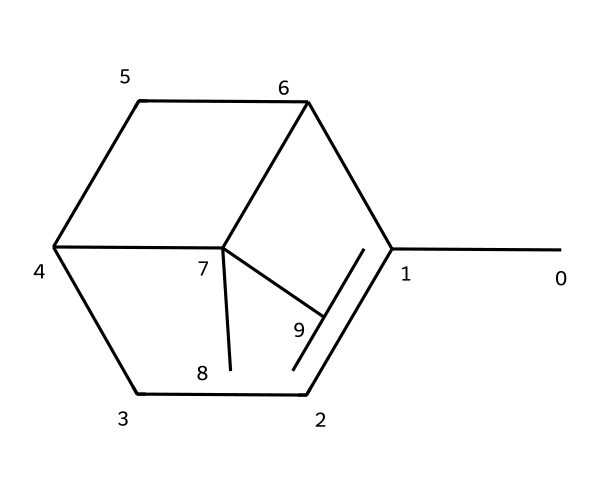What is the primary type of carbon backbone found in alpha-pinene? The primary type of carbon backbone in alpha-pinene is a bicyclic structure, which consists of two fused rings. This structure is characteristic of many terpenes.
Answer: bicyclic How many carbon atoms are in the molecule of alpha-pinene? By analyzing the SMILES representation, we can count the number of 'C' atoms. In this case, there are 10 carbon atoms present in the molecular structure of alpha-pinene.
Answer: 10 What functional group is commonly associated with terpenes like alpha-pinene? Terpenes commonly contain double bonds due to their unsaturated hydrocarbon nature. In the case of alpha-pinene, there are several double bonds in the structure contributing to its chemical properties.
Answer: double bond Is alpha-pinene a saturated or unsaturated compound? The presence of double bonds in alpha-pinene indicates that it is not fully saturated with hydrogen atoms, thus categorizing it as an unsaturated compound.
Answer: unsaturated What type of isomerism does alpha-pinene exhibit? Alpha-pinene can exhibit structural isomerism due to its different possible arrangements, including different positions of double bonds or branching in the molecule while maintaining the same molecular formula.
Answer: structural isomerism What is a potential application of alpha-pinene in computing algorithms? Alpha-pinene's characteristics inspire bioinspired computing algorithms, particularly in optimization problems, mimicking natural processes of search and adaptation.
Answer: optimization 